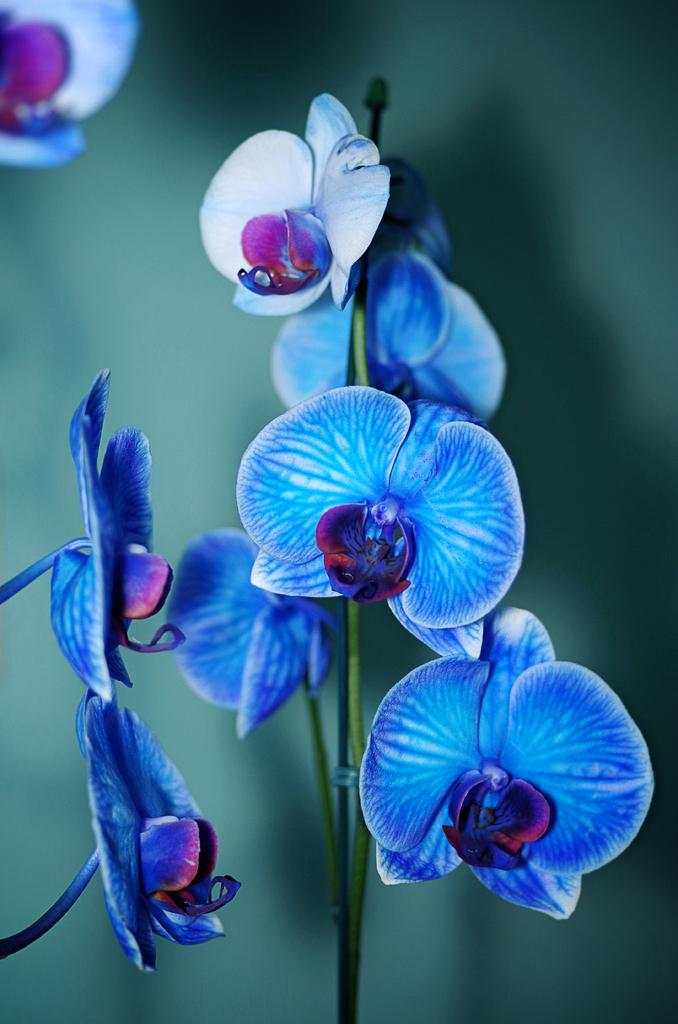What type of plants are in the image? The image contains flowers. What colors are the flowers? The flowers are in blue and purple colors. What color is the background of the image? The background is green in color. How is the background of the image depicted? The background is blurred. What type of fear can be seen on the face of the butter in the image? There is no butter present in the image, and therefore no fear can be observed. 